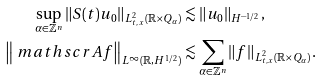<formula> <loc_0><loc_0><loc_500><loc_500>\sup _ { \alpha \in \mathbb { Z } ^ { n } } \| S ( t ) u _ { 0 } \| _ { L ^ { 2 } _ { t , x } ( \mathbb { R } \times Q _ { \alpha } ) } & \lesssim \| u _ { 0 } \| _ { H ^ { - 1 / 2 } } , \\ \left \| \ m a t h s c r { A } f \right \| _ { L ^ { \infty } ( \mathbb { R } , H ^ { 1 / 2 } ) } & \lesssim \sum _ { \alpha \in \mathbb { Z } ^ { n } } \| f \| _ { L ^ { 2 } _ { t , x } ( \mathbb { R } \times Q _ { \alpha } ) } .</formula> 